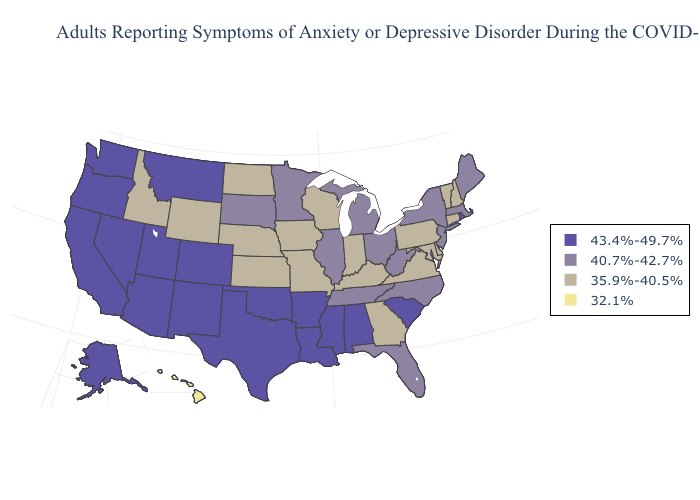What is the value of Delaware?
Write a very short answer. 35.9%-40.5%. Name the states that have a value in the range 40.7%-42.7%?
Quick response, please. Florida, Illinois, Maine, Massachusetts, Michigan, Minnesota, New Jersey, New York, North Carolina, Ohio, South Dakota, Tennessee, West Virginia. Name the states that have a value in the range 40.7%-42.7%?
Be succinct. Florida, Illinois, Maine, Massachusetts, Michigan, Minnesota, New Jersey, New York, North Carolina, Ohio, South Dakota, Tennessee, West Virginia. Name the states that have a value in the range 35.9%-40.5%?
Be succinct. Connecticut, Delaware, Georgia, Idaho, Indiana, Iowa, Kansas, Kentucky, Maryland, Missouri, Nebraska, New Hampshire, North Dakota, Pennsylvania, Vermont, Virginia, Wisconsin, Wyoming. Does Louisiana have the highest value in the South?
Answer briefly. Yes. Among the states that border Idaho , does Wyoming have the lowest value?
Concise answer only. Yes. What is the value of New Jersey?
Be succinct. 40.7%-42.7%. What is the value of Tennessee?
Quick response, please. 40.7%-42.7%. Name the states that have a value in the range 35.9%-40.5%?
Answer briefly. Connecticut, Delaware, Georgia, Idaho, Indiana, Iowa, Kansas, Kentucky, Maryland, Missouri, Nebraska, New Hampshire, North Dakota, Pennsylvania, Vermont, Virginia, Wisconsin, Wyoming. What is the value of Mississippi?
Answer briefly. 43.4%-49.7%. Which states have the lowest value in the USA?
Short answer required. Hawaii. What is the highest value in the USA?
Keep it brief. 43.4%-49.7%. Name the states that have a value in the range 43.4%-49.7%?
Answer briefly. Alabama, Alaska, Arizona, Arkansas, California, Colorado, Louisiana, Mississippi, Montana, Nevada, New Mexico, Oklahoma, Oregon, Rhode Island, South Carolina, Texas, Utah, Washington. What is the value of Minnesota?
Quick response, please. 40.7%-42.7%. Does the map have missing data?
Concise answer only. No. 